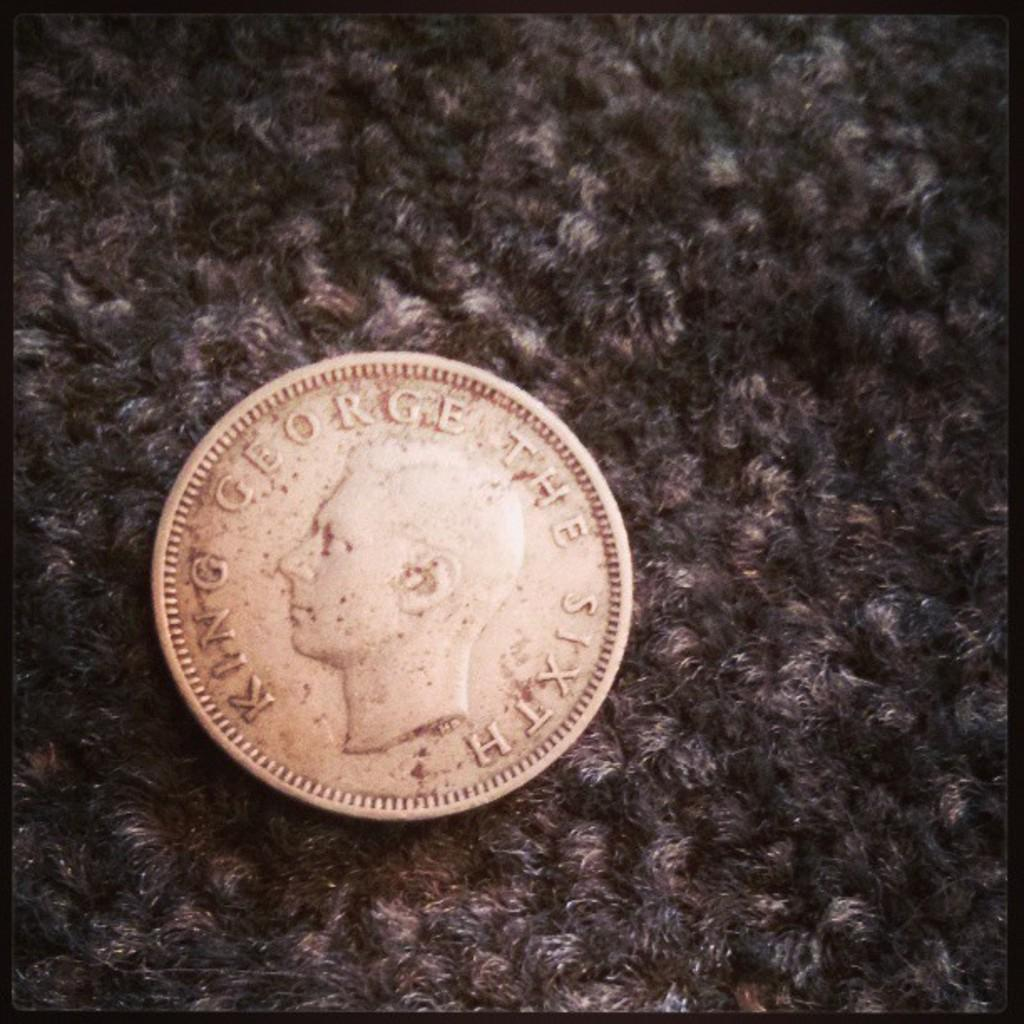<image>
Summarize the visual content of the image. King George the Sixth coin in a bronze type color. 